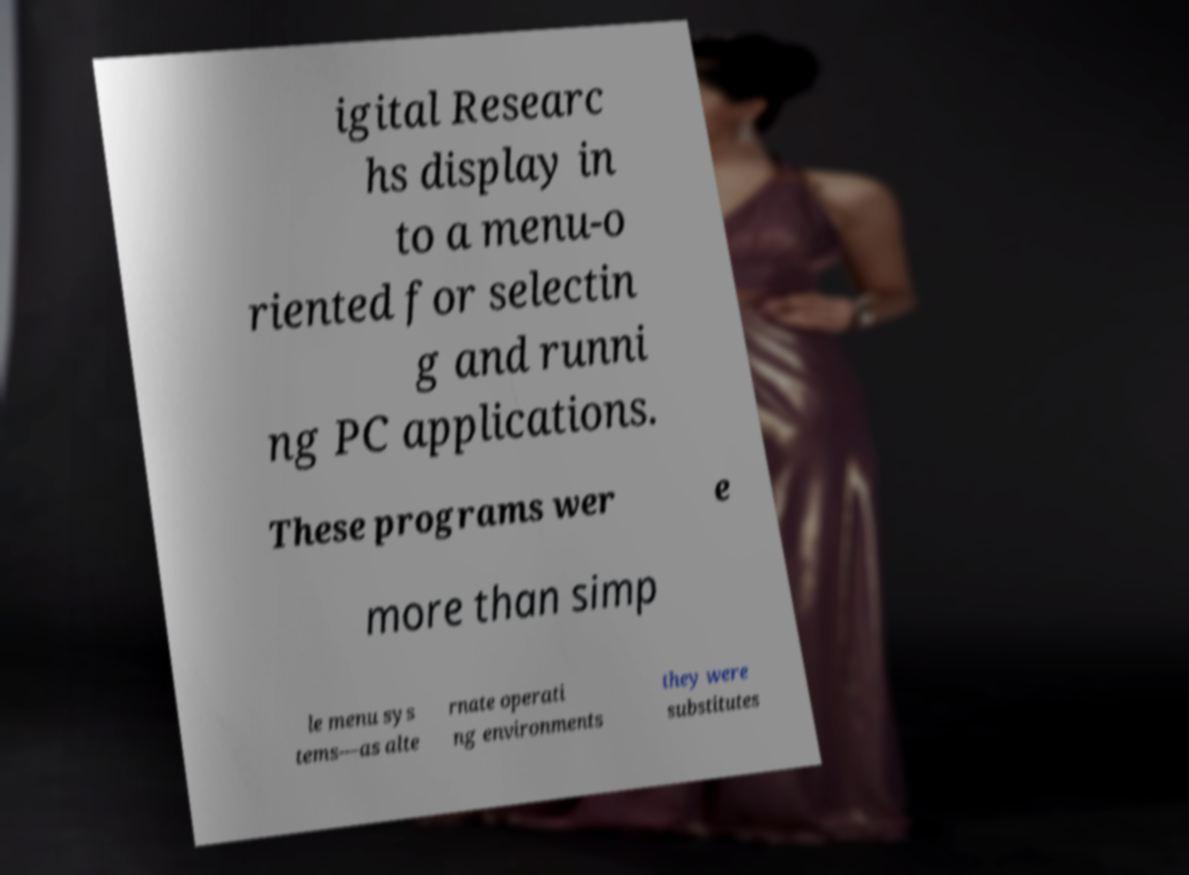Could you extract and type out the text from this image? igital Researc hs display in to a menu-o riented for selectin g and runni ng PC applications. These programs wer e more than simp le menu sys tems—as alte rnate operati ng environments they were substitutes 